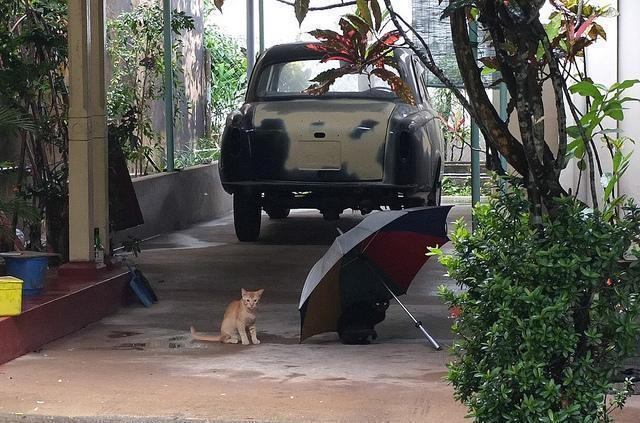How many cats are shown?
Give a very brief answer. 1. 